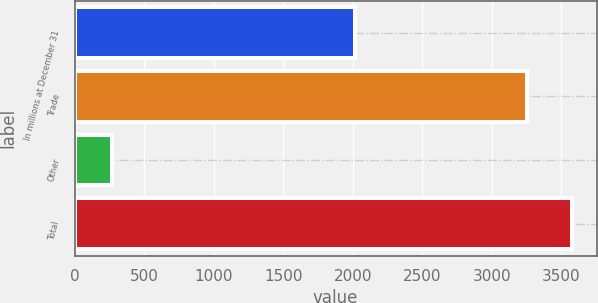<chart> <loc_0><loc_0><loc_500><loc_500><bar_chart><fcel>In millions at December 31<fcel>Trade<fcel>Other<fcel>Total<nl><fcel>2018<fcel>3249<fcel>272<fcel>3573.9<nl></chart> 